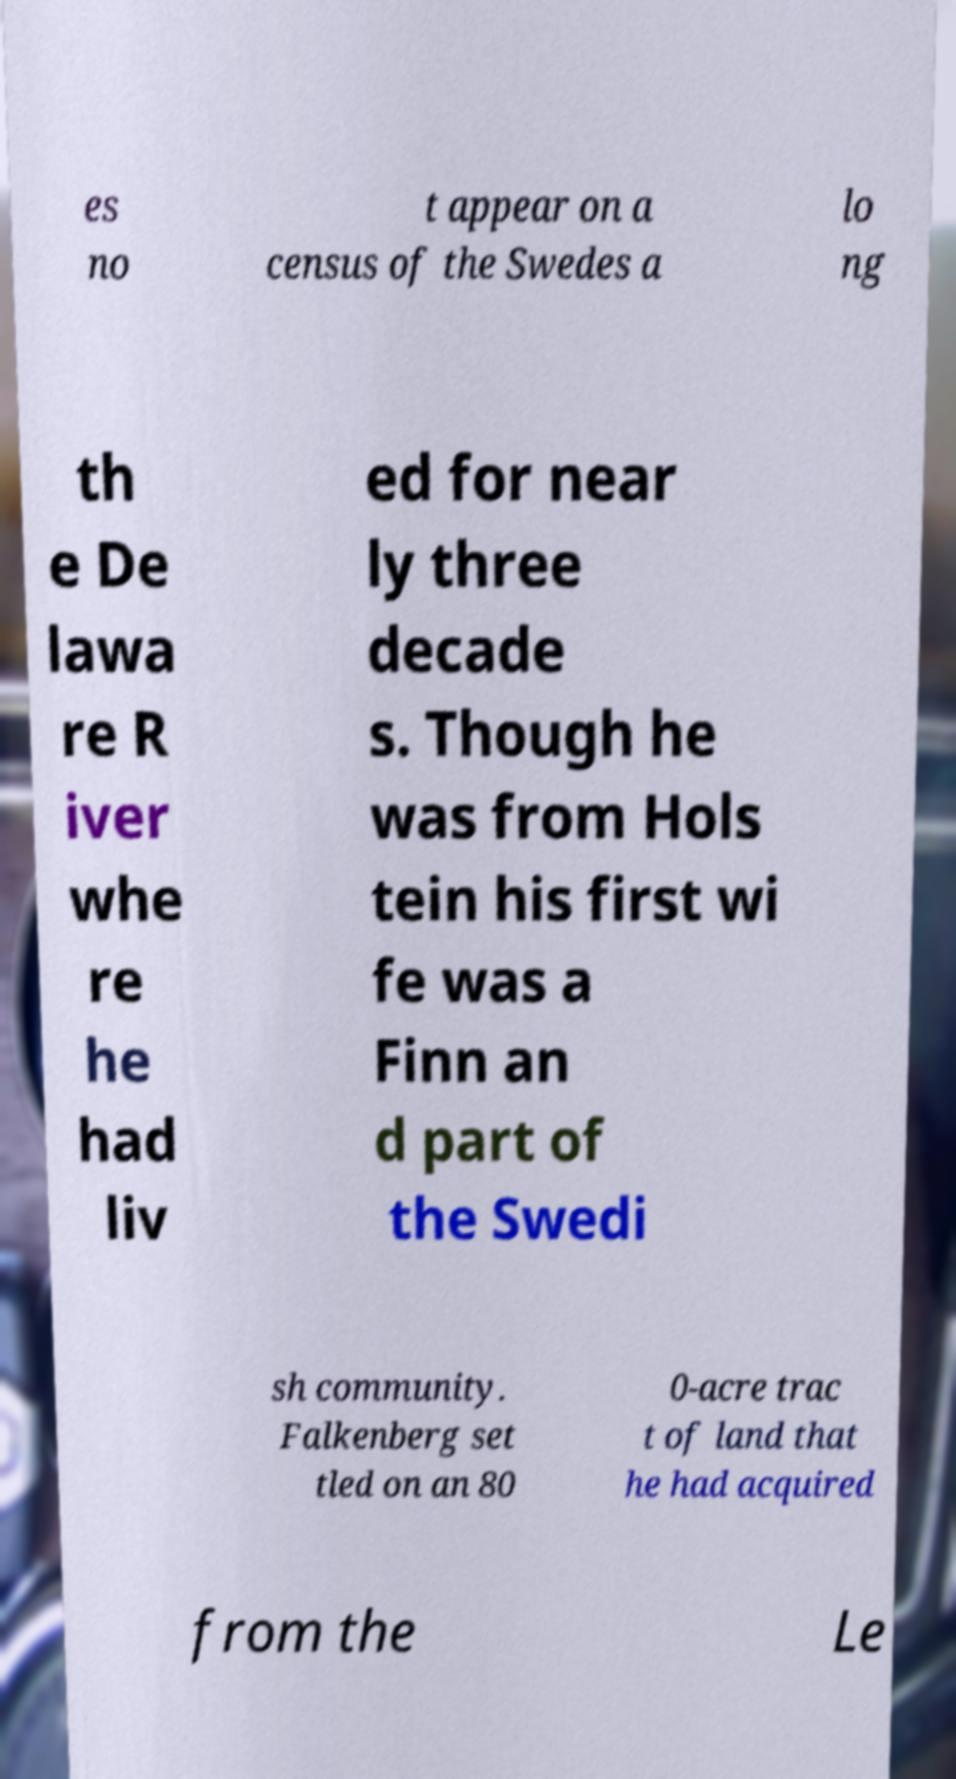Can you accurately transcribe the text from the provided image for me? es no t appear on a census of the Swedes a lo ng th e De lawa re R iver whe re he had liv ed for near ly three decade s. Though he was from Hols tein his first wi fe was a Finn an d part of the Swedi sh community. Falkenberg set tled on an 80 0-acre trac t of land that he had acquired from the Le 